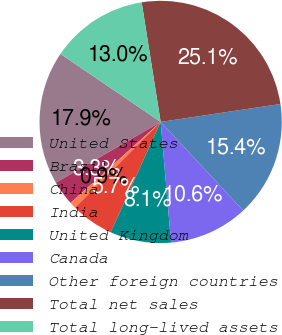Convert chart. <chart><loc_0><loc_0><loc_500><loc_500><pie_chart><fcel>United States<fcel>Brazil<fcel>China<fcel>India<fcel>United Kingdom<fcel>Canada<fcel>Other foreign countries<fcel>Total net sales<fcel>Total long-lived assets<nl><fcel>17.86%<fcel>3.29%<fcel>0.86%<fcel>5.72%<fcel>8.14%<fcel>10.57%<fcel>15.43%<fcel>25.14%<fcel>13.0%<nl></chart> 